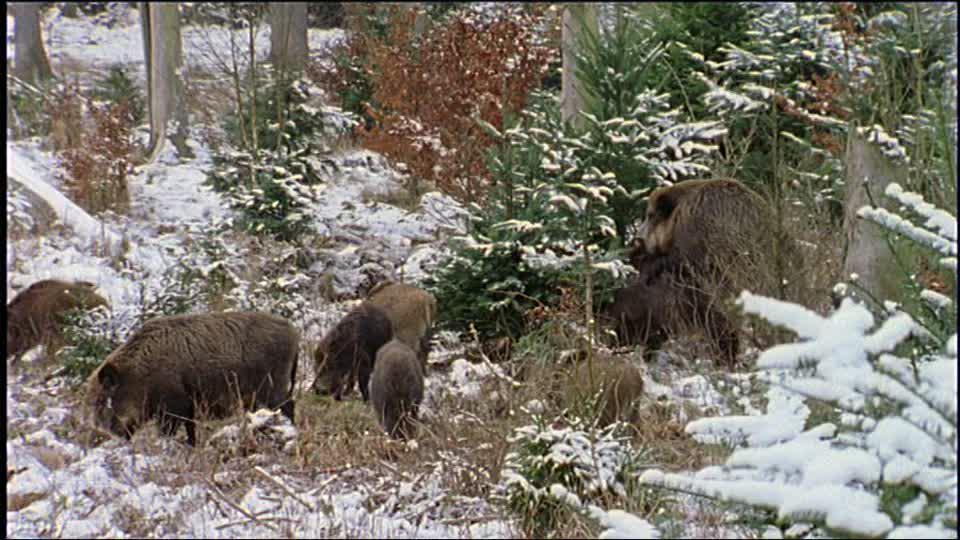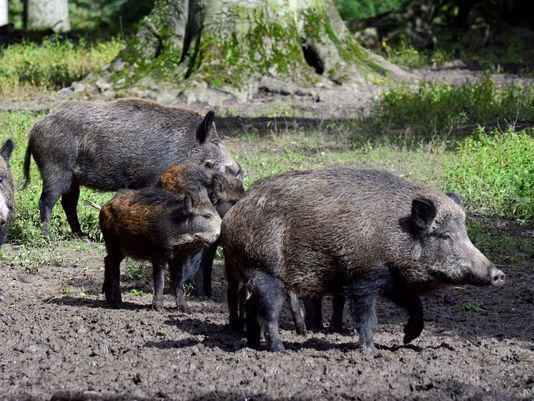The first image is the image on the left, the second image is the image on the right. Given the left and right images, does the statement "The right image contains exactly two pigs." hold true? Answer yes or no. No. The first image is the image on the left, the second image is the image on the right. Evaluate the accuracy of this statement regarding the images: "An image includes at least one tusked boar lying on the ground, and at least one other kind of mammal in the picture.". Is it true? Answer yes or no. No. 